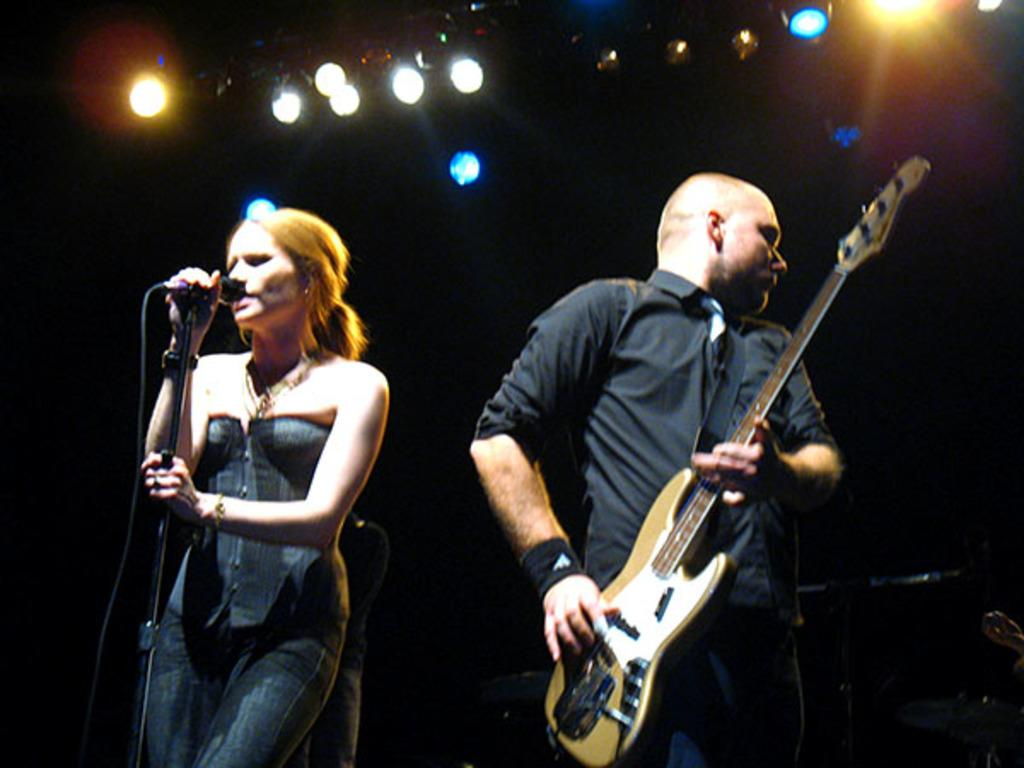What is on top of the structure in the image? There are focusing lights on top in the image. What is the woman in the image doing? The woman is holding a mic and singing. What instrument is the man playing in the image? The man is playing a guitar. What color is the shirt the man is wearing? The man is wearing a black shirt. How many trucks are visible in the image? There are no trucks present in the image. What type of engine is being used by the woman to sing? The woman is singing without the use of an engine; she is using a microphone. 